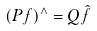Convert formula to latex. <formula><loc_0><loc_0><loc_500><loc_500>( P f ) ^ { \wedge } = Q \hat { f }</formula> 